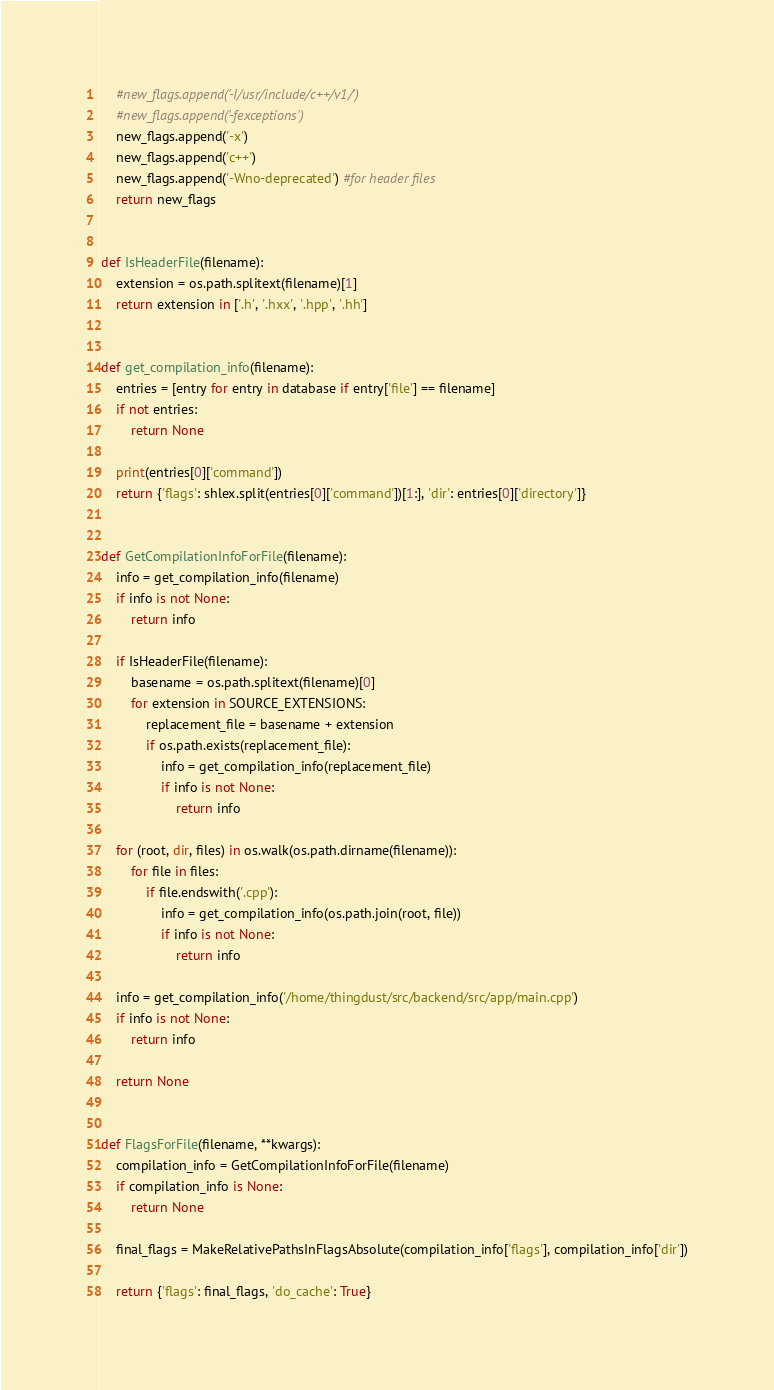Convert code to text. <code><loc_0><loc_0><loc_500><loc_500><_Python_>    #new_flags.append('-I/usr/include/c++/v1/')
    #new_flags.append('-fexceptions')
    new_flags.append('-x')
    new_flags.append('c++')
    new_flags.append('-Wno-deprecated') #for header files
    return new_flags


def IsHeaderFile(filename):
    extension = os.path.splitext(filename)[1]
    return extension in ['.h', '.hxx', '.hpp', '.hh']


def get_compilation_info(filename):
    entries = [entry for entry in database if entry['file'] == filename]
    if not entries:
        return None

    print(entries[0]['command'])
    return {'flags': shlex.split(entries[0]['command'])[1:], 'dir': entries[0]['directory']}


def GetCompilationInfoForFile(filename):
    info = get_compilation_info(filename)
    if info is not None:
        return info

    if IsHeaderFile(filename):
        basename = os.path.splitext(filename)[0]
        for extension in SOURCE_EXTENSIONS:
            replacement_file = basename + extension
            if os.path.exists(replacement_file):
                info = get_compilation_info(replacement_file)
                if info is not None:
                    return info

    for (root, dir, files) in os.walk(os.path.dirname(filename)):
        for file in files:
            if file.endswith('.cpp'):
                info = get_compilation_info(os.path.join(root, file))
                if info is not None:
                    return info

    info = get_compilation_info('/home/thingdust/src/backend/src/app/main.cpp')
    if info is not None:
        return info

    return None


def FlagsForFile(filename, **kwargs):
    compilation_info = GetCompilationInfoForFile(filename)
    if compilation_info is None:
        return None

    final_flags = MakeRelativePathsInFlagsAbsolute(compilation_info['flags'], compilation_info['dir'])

    return {'flags': final_flags, 'do_cache': True}
</code> 